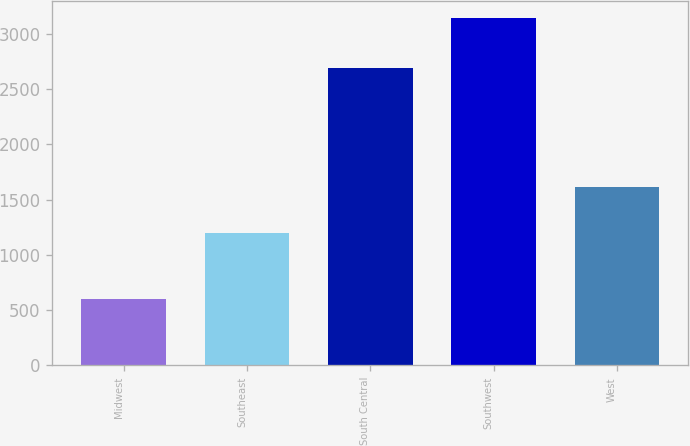<chart> <loc_0><loc_0><loc_500><loc_500><bar_chart><fcel>Midwest<fcel>Southeast<fcel>South Central<fcel>Southwest<fcel>West<nl><fcel>600<fcel>1198<fcel>2693<fcel>3139<fcel>1618<nl></chart> 